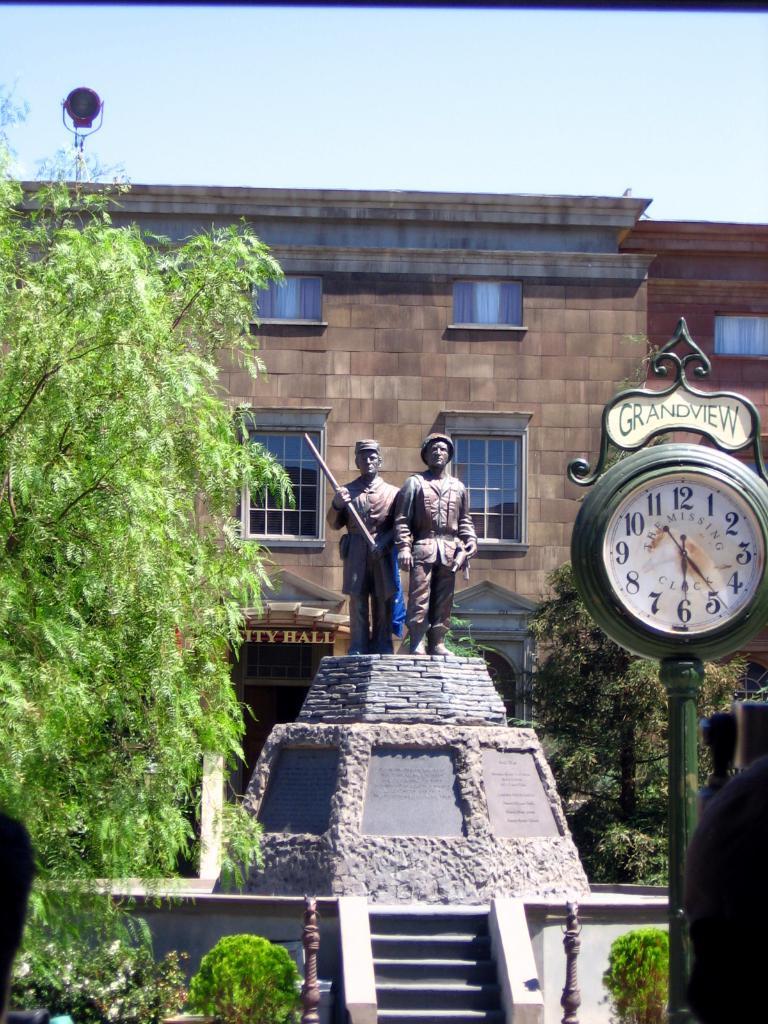What kind of view is the clock?
Provide a short and direct response. Grandview. What time is it?
Offer a terse response. 6:24. 